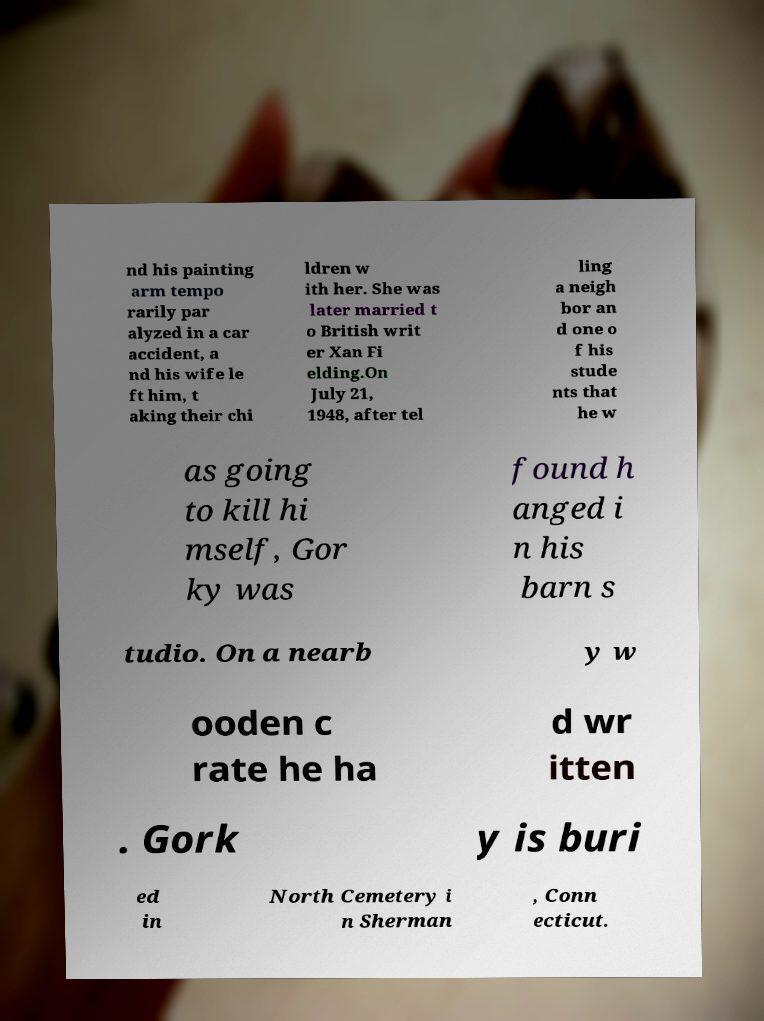Can you read and provide the text displayed in the image?This photo seems to have some interesting text. Can you extract and type it out for me? nd his painting arm tempo rarily par alyzed in a car accident, a nd his wife le ft him, t aking their chi ldren w ith her. She was later married t o British writ er Xan Fi elding.On July 21, 1948, after tel ling a neigh bor an d one o f his stude nts that he w as going to kill hi mself, Gor ky was found h anged i n his barn s tudio. On a nearb y w ooden c rate he ha d wr itten . Gork y is buri ed in North Cemetery i n Sherman , Conn ecticut. 